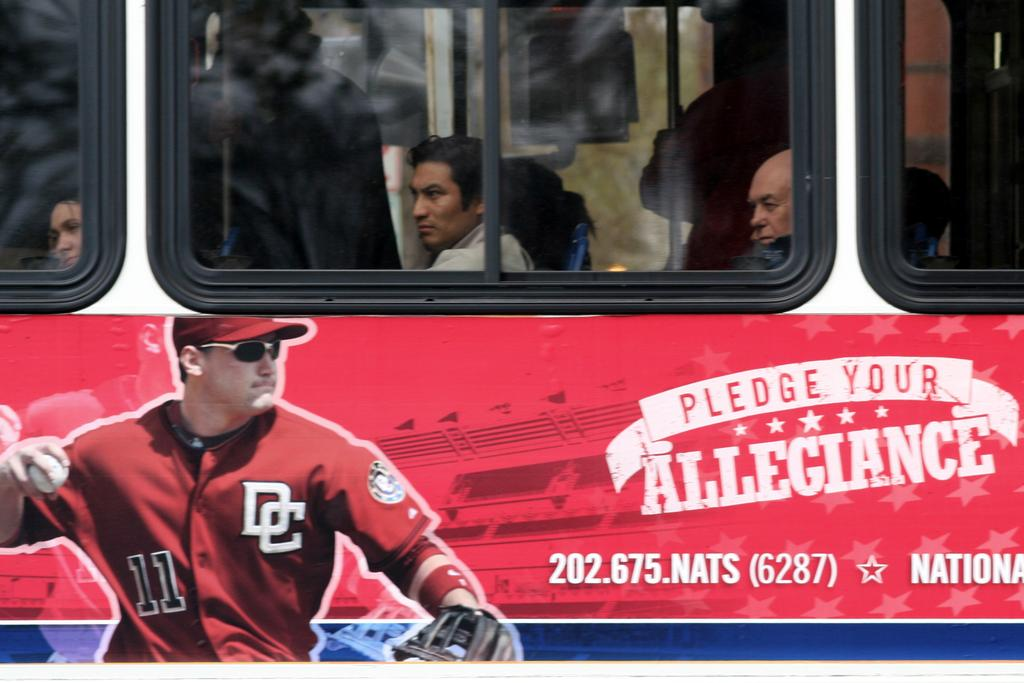<image>
Write a terse but informative summary of the picture. An ad shows a man in a baseball jersey with the number 11 on it. 